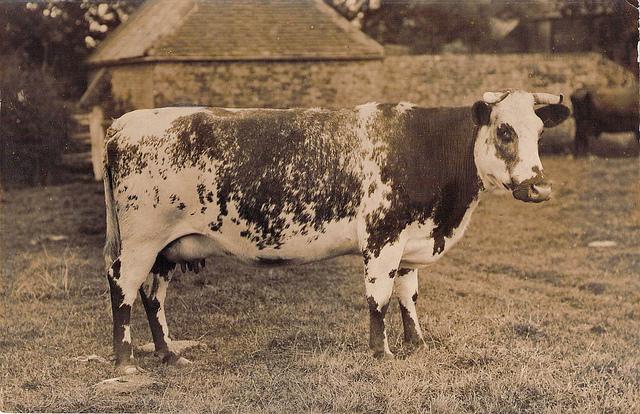Is this steer a solid color?
Concise answer only. No. What direction is the tail facing?
Give a very brief answer. Down. Where is the cow going?
Be succinct. Home. Is this a mature steer?
Short answer required. Yes. 